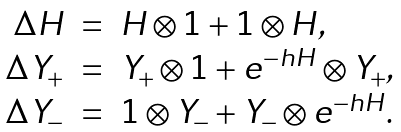Convert formula to latex. <formula><loc_0><loc_0><loc_500><loc_500>\begin{array} { r c l } \Delta H & = & H \otimes { 1 } + { 1 } \otimes H , \\ \Delta Y _ { + } & = & Y _ { + } \otimes { 1 } + e ^ { - h H } \otimes Y _ { + } , \\ \Delta Y _ { - } & = & { 1 } \otimes Y _ { - } + Y _ { - } \otimes e ^ { - h H } . \end{array}</formula> 